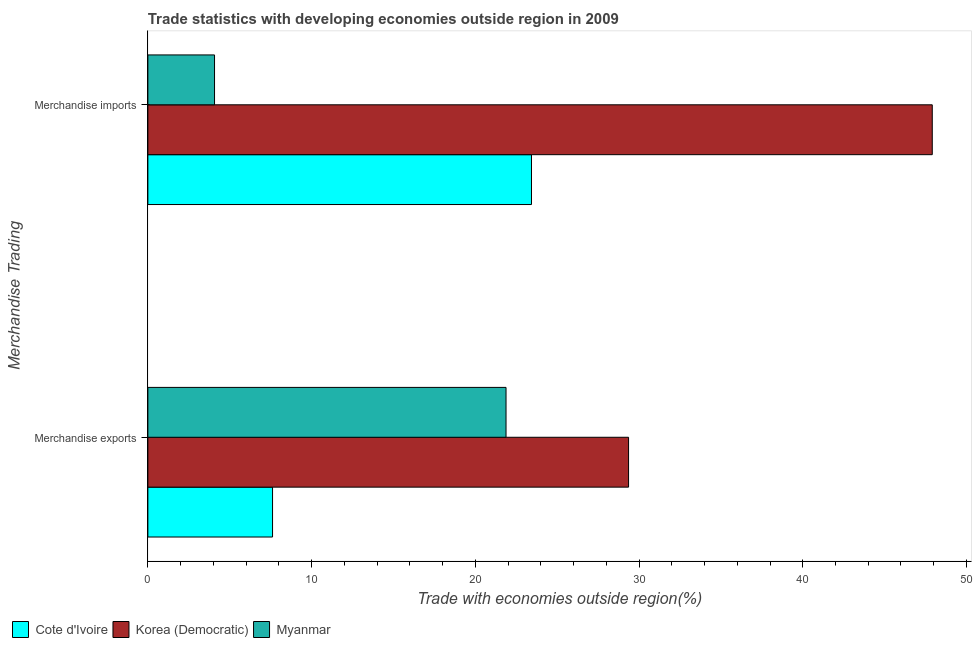How many groups of bars are there?
Give a very brief answer. 2. How many bars are there on the 2nd tick from the bottom?
Offer a very short reply. 3. What is the label of the 1st group of bars from the top?
Ensure brevity in your answer.  Merchandise imports. What is the merchandise exports in Korea (Democratic)?
Keep it short and to the point. 29.36. Across all countries, what is the maximum merchandise exports?
Provide a succinct answer. 29.36. Across all countries, what is the minimum merchandise imports?
Keep it short and to the point. 4.07. In which country was the merchandise imports maximum?
Give a very brief answer. Korea (Democratic). In which country was the merchandise exports minimum?
Provide a short and direct response. Cote d'Ivoire. What is the total merchandise exports in the graph?
Provide a succinct answer. 58.85. What is the difference between the merchandise exports in Myanmar and that in Cote d'Ivoire?
Give a very brief answer. 14.26. What is the difference between the merchandise exports in Korea (Democratic) and the merchandise imports in Cote d'Ivoire?
Ensure brevity in your answer.  5.93. What is the average merchandise imports per country?
Offer a terse response. 25.14. What is the difference between the merchandise exports and merchandise imports in Korea (Democratic)?
Keep it short and to the point. -18.55. What is the ratio of the merchandise exports in Korea (Democratic) to that in Cote d'Ivoire?
Keep it short and to the point. 3.86. What does the 3rd bar from the top in Merchandise imports represents?
Give a very brief answer. Cote d'Ivoire. What does the 2nd bar from the bottom in Merchandise exports represents?
Provide a short and direct response. Korea (Democratic). Are all the bars in the graph horizontal?
Provide a short and direct response. Yes. What is the difference between two consecutive major ticks on the X-axis?
Ensure brevity in your answer.  10. Does the graph contain any zero values?
Keep it short and to the point. No. How many legend labels are there?
Your response must be concise. 3. What is the title of the graph?
Keep it short and to the point. Trade statistics with developing economies outside region in 2009. Does "Vietnam" appear as one of the legend labels in the graph?
Your response must be concise. No. What is the label or title of the X-axis?
Provide a succinct answer. Trade with economies outside region(%). What is the label or title of the Y-axis?
Make the answer very short. Merchandise Trading. What is the Trade with economies outside region(%) in Cote d'Ivoire in Merchandise exports?
Keep it short and to the point. 7.62. What is the Trade with economies outside region(%) of Korea (Democratic) in Merchandise exports?
Offer a terse response. 29.36. What is the Trade with economies outside region(%) of Myanmar in Merchandise exports?
Provide a succinct answer. 21.88. What is the Trade with economies outside region(%) in Cote d'Ivoire in Merchandise imports?
Give a very brief answer. 23.43. What is the Trade with economies outside region(%) in Korea (Democratic) in Merchandise imports?
Your answer should be compact. 47.91. What is the Trade with economies outside region(%) in Myanmar in Merchandise imports?
Your answer should be compact. 4.07. Across all Merchandise Trading, what is the maximum Trade with economies outside region(%) in Cote d'Ivoire?
Provide a succinct answer. 23.43. Across all Merchandise Trading, what is the maximum Trade with economies outside region(%) in Korea (Democratic)?
Provide a short and direct response. 47.91. Across all Merchandise Trading, what is the maximum Trade with economies outside region(%) of Myanmar?
Make the answer very short. 21.88. Across all Merchandise Trading, what is the minimum Trade with economies outside region(%) in Cote d'Ivoire?
Make the answer very short. 7.62. Across all Merchandise Trading, what is the minimum Trade with economies outside region(%) of Korea (Democratic)?
Your answer should be very brief. 29.36. Across all Merchandise Trading, what is the minimum Trade with economies outside region(%) in Myanmar?
Ensure brevity in your answer.  4.07. What is the total Trade with economies outside region(%) of Cote d'Ivoire in the graph?
Ensure brevity in your answer.  31.05. What is the total Trade with economies outside region(%) in Korea (Democratic) in the graph?
Your response must be concise. 77.27. What is the total Trade with economies outside region(%) in Myanmar in the graph?
Offer a terse response. 25.95. What is the difference between the Trade with economies outside region(%) of Cote d'Ivoire in Merchandise exports and that in Merchandise imports?
Provide a succinct answer. -15.82. What is the difference between the Trade with economies outside region(%) of Korea (Democratic) in Merchandise exports and that in Merchandise imports?
Offer a terse response. -18.55. What is the difference between the Trade with economies outside region(%) of Myanmar in Merchandise exports and that in Merchandise imports?
Provide a short and direct response. 17.81. What is the difference between the Trade with economies outside region(%) in Cote d'Ivoire in Merchandise exports and the Trade with economies outside region(%) in Korea (Democratic) in Merchandise imports?
Your answer should be compact. -40.3. What is the difference between the Trade with economies outside region(%) of Cote d'Ivoire in Merchandise exports and the Trade with economies outside region(%) of Myanmar in Merchandise imports?
Provide a succinct answer. 3.54. What is the difference between the Trade with economies outside region(%) in Korea (Democratic) in Merchandise exports and the Trade with economies outside region(%) in Myanmar in Merchandise imports?
Make the answer very short. 25.29. What is the average Trade with economies outside region(%) in Cote d'Ivoire per Merchandise Trading?
Your response must be concise. 15.52. What is the average Trade with economies outside region(%) in Korea (Democratic) per Merchandise Trading?
Ensure brevity in your answer.  38.64. What is the average Trade with economies outside region(%) of Myanmar per Merchandise Trading?
Offer a very short reply. 12.97. What is the difference between the Trade with economies outside region(%) in Cote d'Ivoire and Trade with economies outside region(%) in Korea (Democratic) in Merchandise exports?
Your response must be concise. -21.75. What is the difference between the Trade with economies outside region(%) in Cote d'Ivoire and Trade with economies outside region(%) in Myanmar in Merchandise exports?
Keep it short and to the point. -14.26. What is the difference between the Trade with economies outside region(%) in Korea (Democratic) and Trade with economies outside region(%) in Myanmar in Merchandise exports?
Ensure brevity in your answer.  7.48. What is the difference between the Trade with economies outside region(%) of Cote d'Ivoire and Trade with economies outside region(%) of Korea (Democratic) in Merchandise imports?
Your answer should be compact. -24.48. What is the difference between the Trade with economies outside region(%) in Cote d'Ivoire and Trade with economies outside region(%) in Myanmar in Merchandise imports?
Provide a short and direct response. 19.36. What is the difference between the Trade with economies outside region(%) of Korea (Democratic) and Trade with economies outside region(%) of Myanmar in Merchandise imports?
Your answer should be compact. 43.84. What is the ratio of the Trade with economies outside region(%) in Cote d'Ivoire in Merchandise exports to that in Merchandise imports?
Your response must be concise. 0.33. What is the ratio of the Trade with economies outside region(%) in Korea (Democratic) in Merchandise exports to that in Merchandise imports?
Give a very brief answer. 0.61. What is the ratio of the Trade with economies outside region(%) of Myanmar in Merchandise exports to that in Merchandise imports?
Make the answer very short. 5.37. What is the difference between the highest and the second highest Trade with economies outside region(%) of Cote d'Ivoire?
Offer a very short reply. 15.82. What is the difference between the highest and the second highest Trade with economies outside region(%) of Korea (Democratic)?
Your answer should be very brief. 18.55. What is the difference between the highest and the second highest Trade with economies outside region(%) in Myanmar?
Give a very brief answer. 17.81. What is the difference between the highest and the lowest Trade with economies outside region(%) in Cote d'Ivoire?
Ensure brevity in your answer.  15.82. What is the difference between the highest and the lowest Trade with economies outside region(%) in Korea (Democratic)?
Give a very brief answer. 18.55. What is the difference between the highest and the lowest Trade with economies outside region(%) in Myanmar?
Make the answer very short. 17.81. 